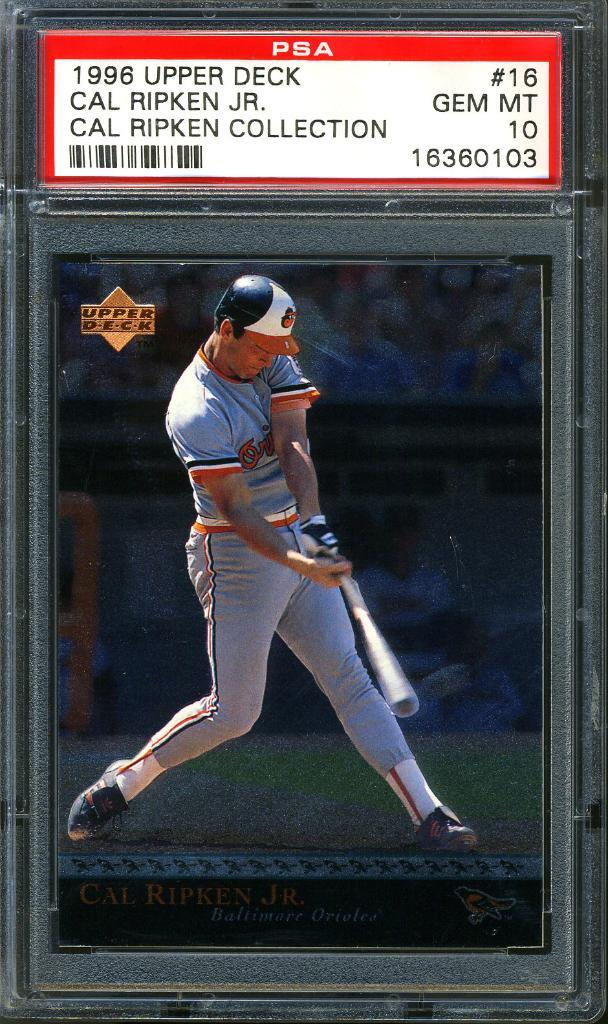Provide a one-sentence caption for the provided image. a baseball card for cal ripken jr in a glass case. 